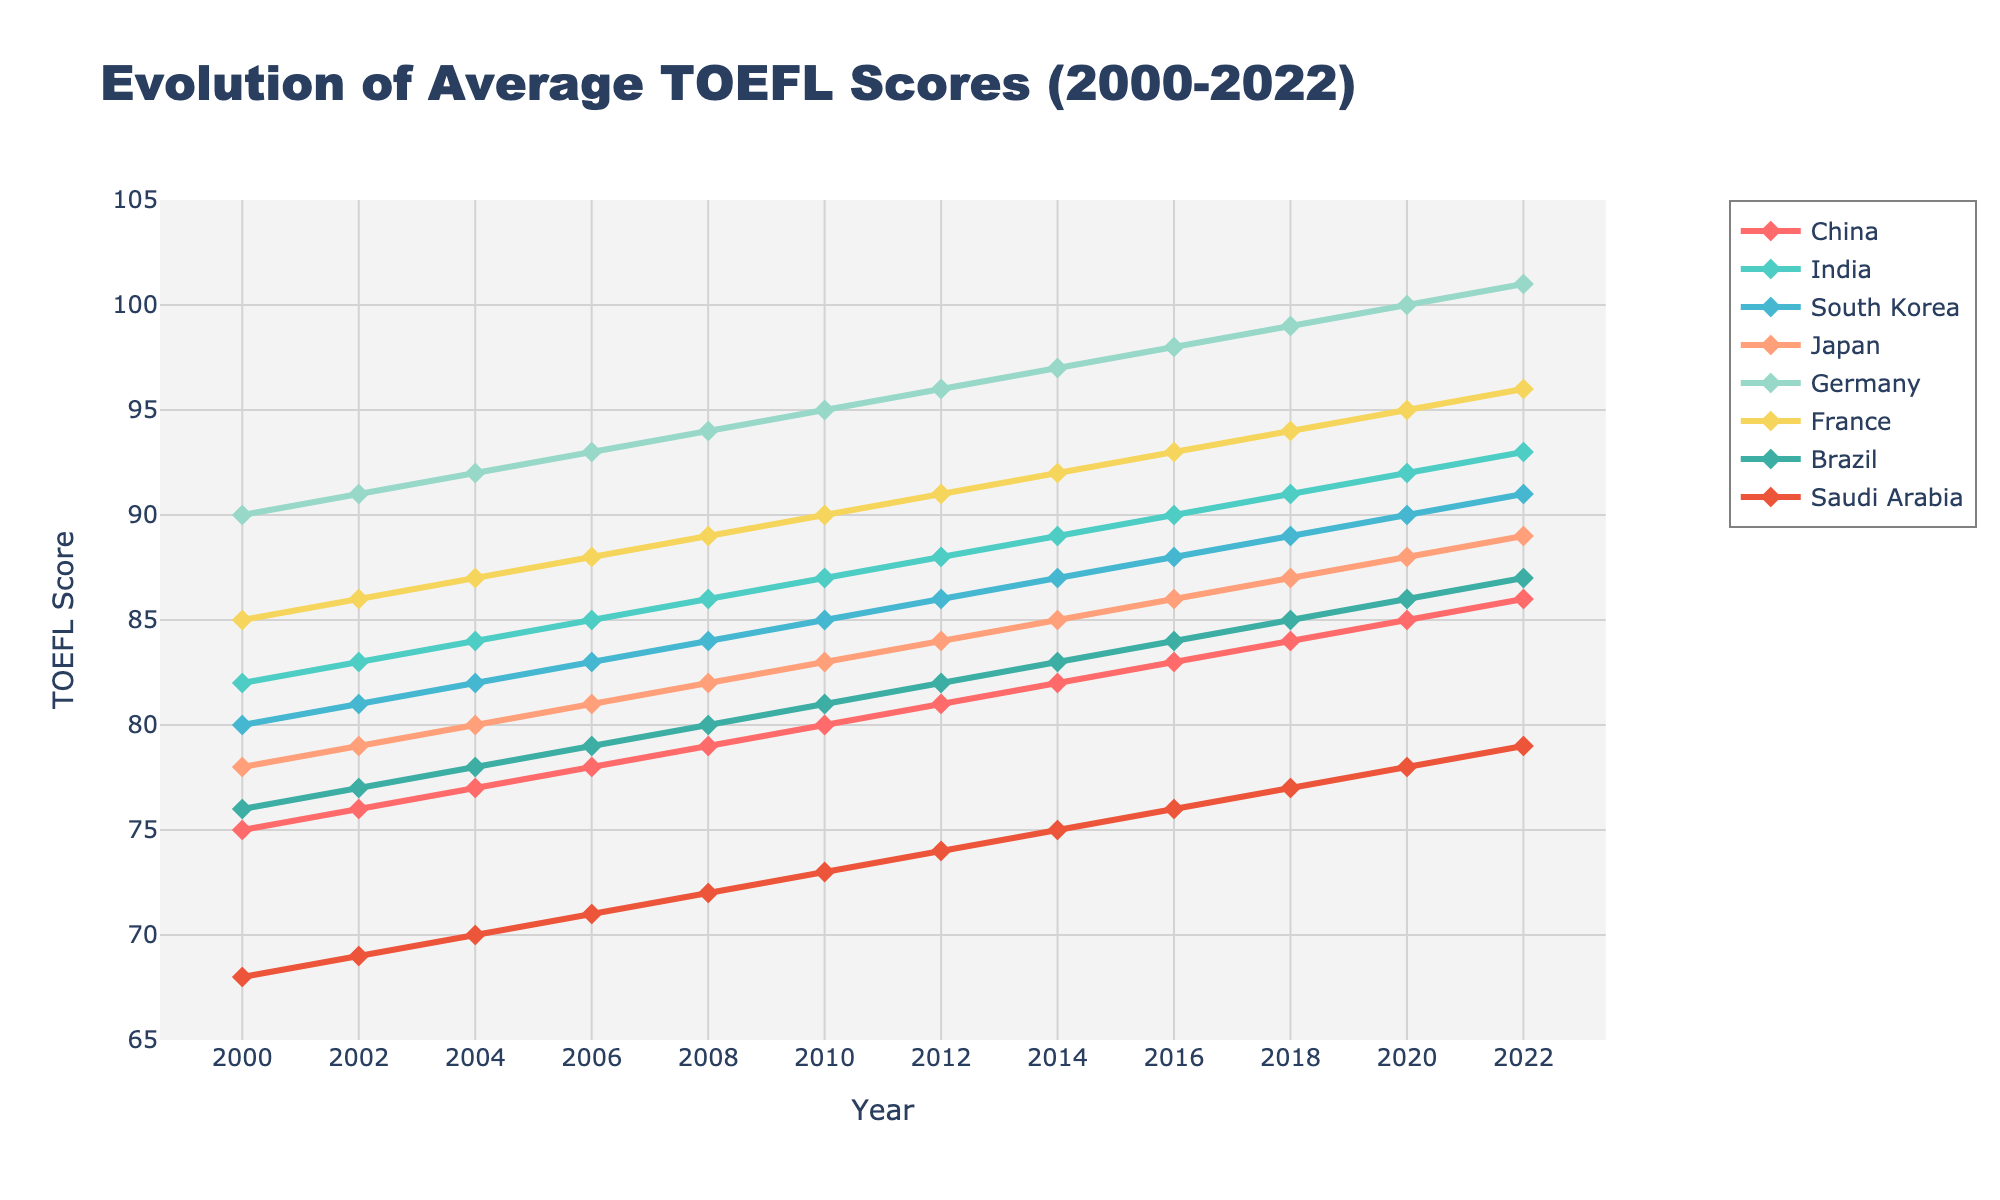Which country shows the highest average TOEFL score in 2022? The y-axis represents the TOEFL scores and the legend indicates different countries. In 2022, you can observe the highest data point corresponds to the line for Germany.
Answer: Germany Between 2010 and 2016, by how many points did South Korea's average TOEFL score increase? Locate the points for South Korea (represented by the matching line and markers) at 2010 and 2016 on the x-axis, then calculate the difference between the two corresponding y-values. South Korea's scores were 85 in 2010 and 88 in 2016, so the increase is 88 - 85.
Answer: 3 points Which two countries have the least difference in their average TOEFL scores in 2006? Compare the TOEFL scores for each country in 2006 visually on the y-axis. China has 78 and India has 85 making the difference 7. Japan has 81, so Japan and Brazil (both have very close scores around 80) have the least difference of about 1 point.
Answer: Japan and South Korea What was the average TOEFL score for France between 2000 and 2022? Calculate the sum of the scores for France from 2000 to 2022 and then divide by the number of years. The scores are 85, 86, 87, 88, 89, 90, 91, 92, 93, 94, 95, 96. Sum these values (85+86+87+88+89+90+91+92+93+94+95+96 = 1066) and divide by 12 (number of years).
Answer: 88.83 In what year did Brazil's average TOEFL score surpass 80? Identify the line representing Brazil and look for the year when its y-value first exceeds 80. This occurs in 2014 when the score reaches just above 80.
Answer: 2014 Which country had a more significant improvement in TOEFL scores from 2000 to 2022, China or Germany? By how much? Look at the scores for China and Germany in the years 2000 and 2022. For China, it rises from 75 to 86 (a difference of 11 points). For Germany, it rises from 90 to 101 (a difference of 11 points). Calculate both differences and compare to determine Germany's higher improvement.
Answer: Germany, by 11 points Which year did the average TOEFL score of Saudi Arabia hit 75? Identify the line corresponding to Saudi Arabia and observe the x-axis to determine when the score intersects 75. According to the graph, this happens around the year 2014.
Answer: 2014 Is it true that the TOEFL scores for every country have been increasing over time? Observe the trend for each country’s line from 2000 to 2022. Each line demonstrates an upward trend without decline, indicating scores have consistently risen for every country over the period.
Answer: True 